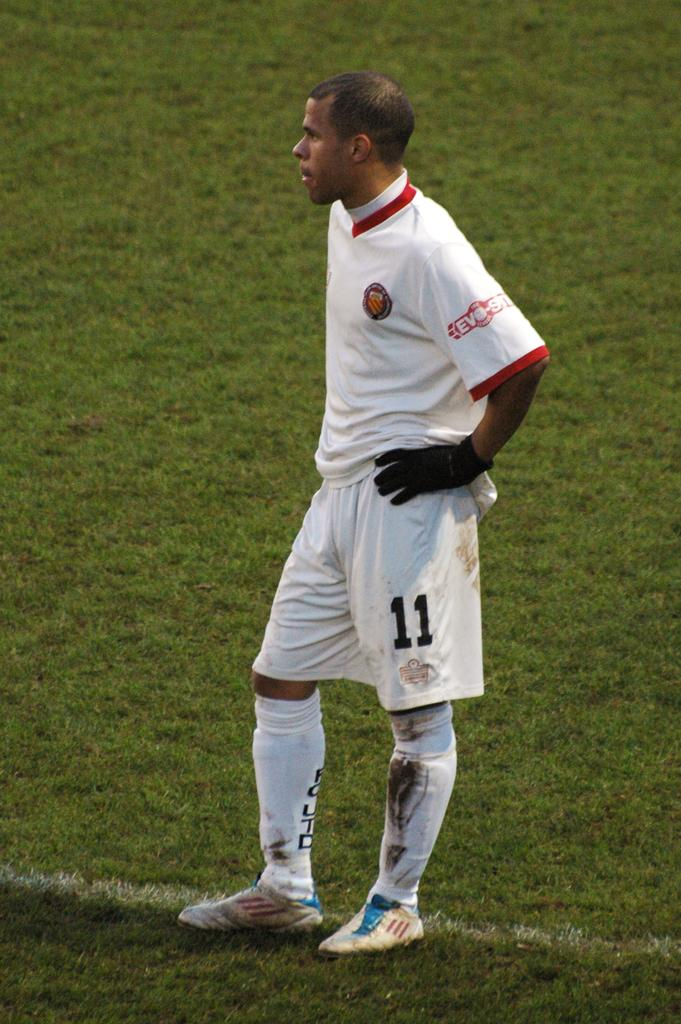<image>
Present a compact description of the photo's key features. Soccer player wearing number 11 standing on the grass. 